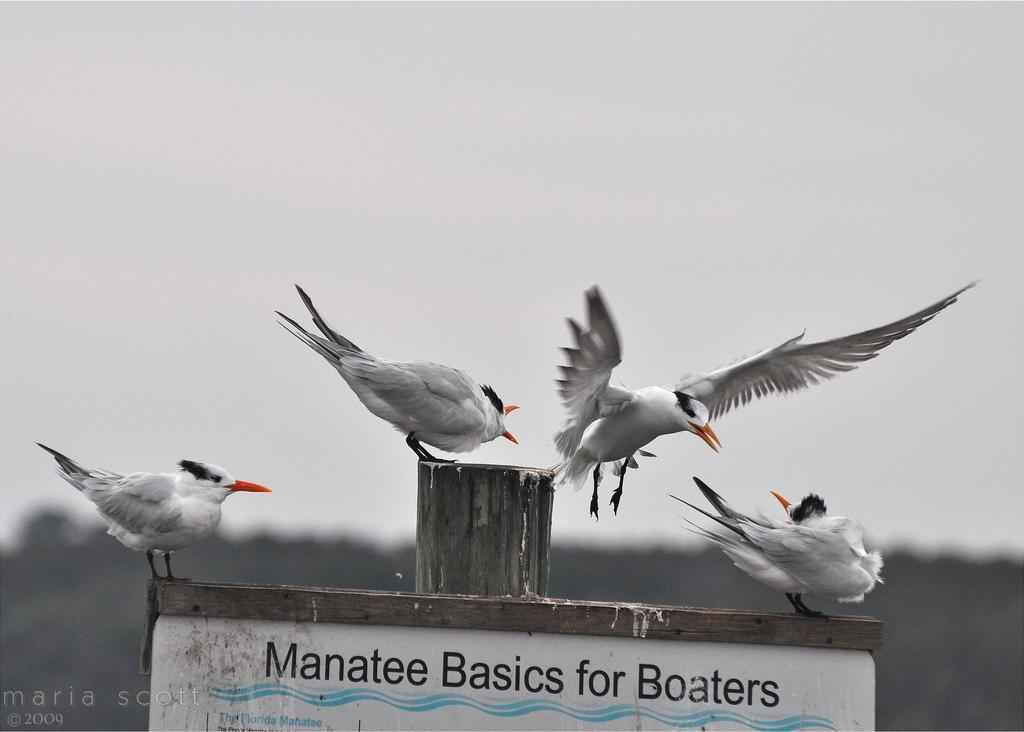How many birds can be seen in the image? There are four birds in the image. What colors do the birds have? The birds have white, black, and orange colors. What objects are present in the image besides the birds? There is a board and a wooden pole in the image. What can be seen in the background of the image? There are trees and the sky visible in the background of the image. What type of cork can be seen on the birds' feet in the image? There are no corks present on the birds' feet in the image. How many teeth can be seen on the birds in the image? Birds do not have teeth, so none can be seen in the image. 